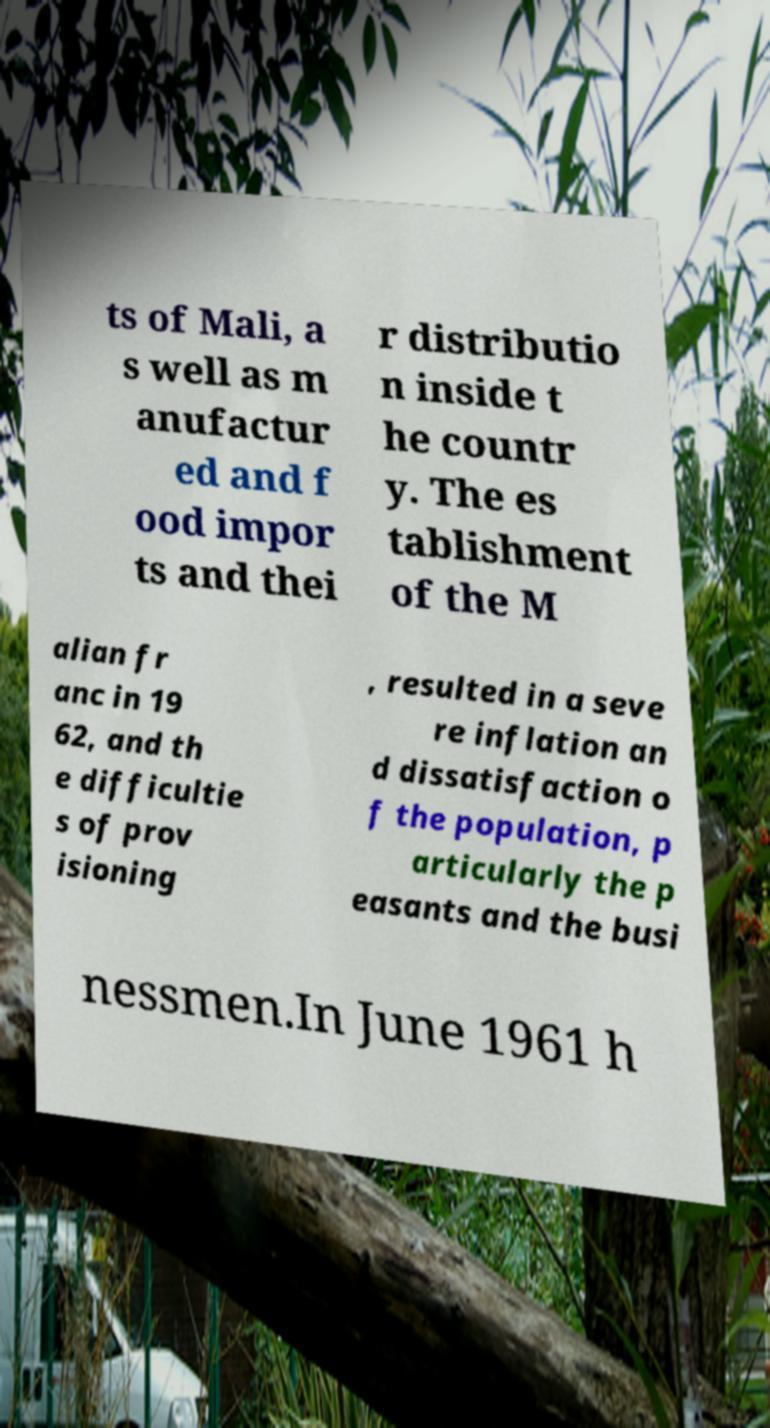Can you accurately transcribe the text from the provided image for me? ts of Mali, a s well as m anufactur ed and f ood impor ts and thei r distributio n inside t he countr y. The es tablishment of the M alian fr anc in 19 62, and th e difficultie s of prov isioning , resulted in a seve re inflation an d dissatisfaction o f the population, p articularly the p easants and the busi nessmen.In June 1961 h 